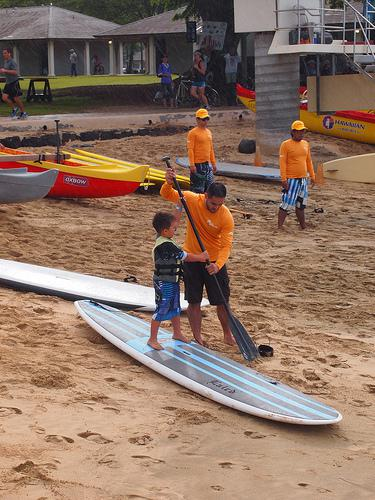Question: what color is the grass?
Choices:
A. Green.
B. Brown.
C. Light green.
D. Dark green.
Answer with the letter. Answer: A Question: where was the picture taken?
Choices:
A. At the beach.
B. By the shore.
C. In the sand.
D. In the water.
Answer with the letter. Answer: C 